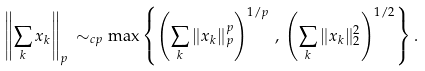Convert formula to latex. <formula><loc_0><loc_0><loc_500><loc_500>\left \| \sum _ { k } x _ { k } \right \| _ { p } \, \sim _ { c p } \max \left \{ \left ( \sum _ { k } \| x _ { k } \| _ { p } ^ { p } \right ) ^ { 1 / p } \, , \, \left ( \sum _ { k } \| x _ { k } \| _ { 2 } ^ { 2 } \right ) ^ { 1 / 2 } \right \} .</formula> 